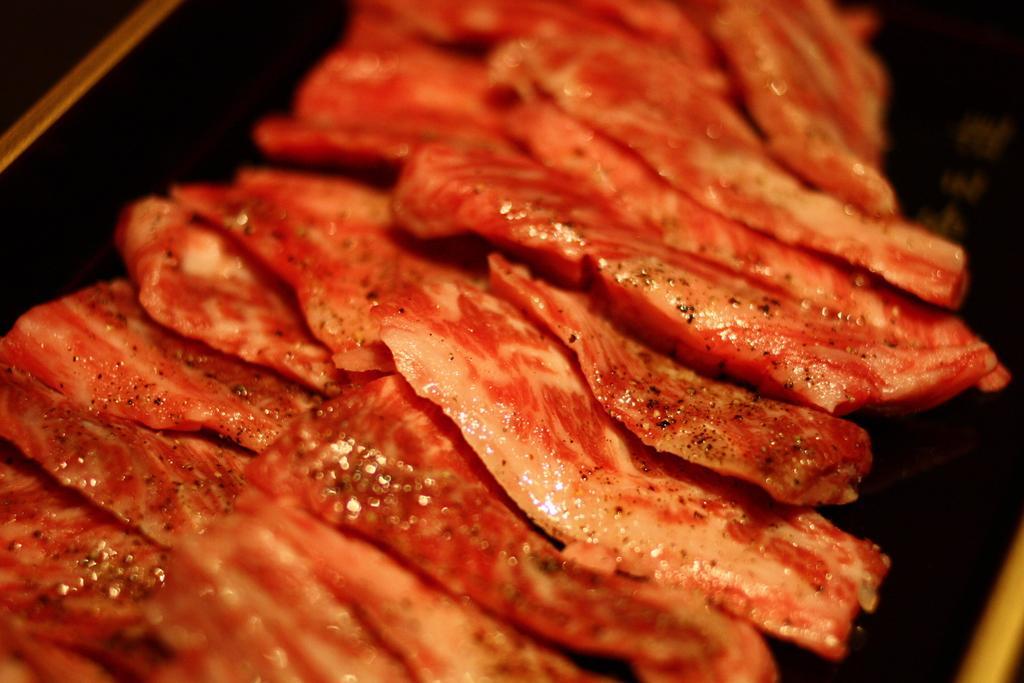Describe this image in one or two sentences. In the foreground of this image, there are slices of meat on the black surface. 